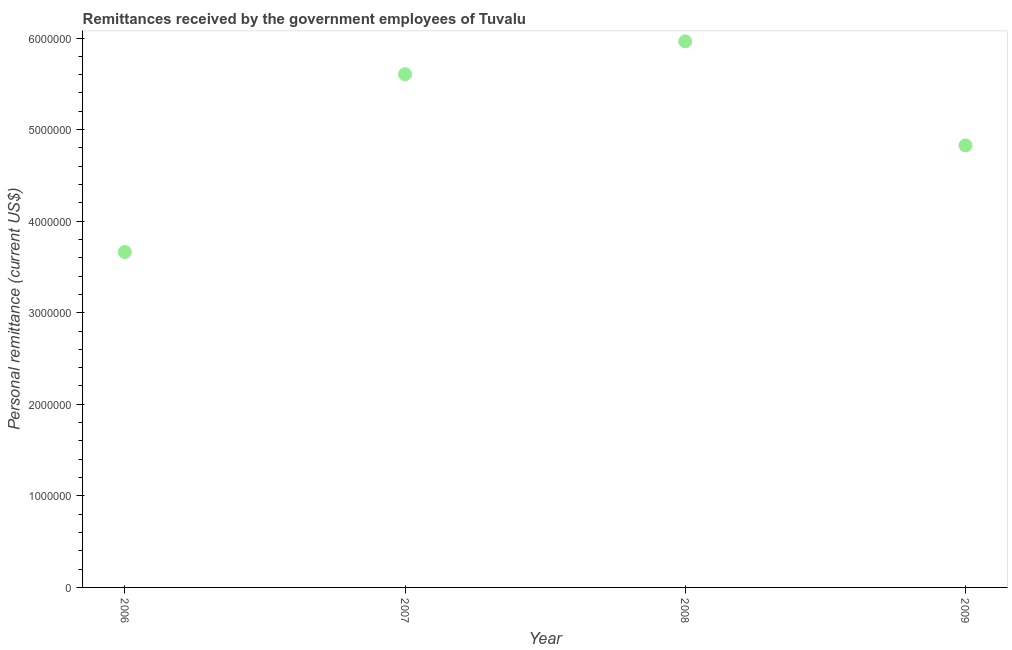What is the personal remittances in 2008?
Ensure brevity in your answer.  5.96e+06. Across all years, what is the maximum personal remittances?
Give a very brief answer. 5.96e+06. Across all years, what is the minimum personal remittances?
Provide a short and direct response. 3.66e+06. What is the sum of the personal remittances?
Provide a short and direct response. 2.01e+07. What is the difference between the personal remittances in 2007 and 2009?
Your answer should be compact. 7.78e+05. What is the average personal remittances per year?
Your answer should be very brief. 5.01e+06. What is the median personal remittances?
Make the answer very short. 5.22e+06. Do a majority of the years between 2009 and 2006 (inclusive) have personal remittances greater than 4800000 US$?
Give a very brief answer. Yes. What is the ratio of the personal remittances in 2007 to that in 2008?
Offer a very short reply. 0.94. What is the difference between the highest and the second highest personal remittances?
Ensure brevity in your answer.  3.59e+05. What is the difference between the highest and the lowest personal remittances?
Ensure brevity in your answer.  2.30e+06. In how many years, is the personal remittances greater than the average personal remittances taken over all years?
Ensure brevity in your answer.  2. Does the personal remittances monotonically increase over the years?
Offer a very short reply. No. How many dotlines are there?
Give a very brief answer. 1. How many years are there in the graph?
Keep it short and to the point. 4. Are the values on the major ticks of Y-axis written in scientific E-notation?
Offer a very short reply. No. What is the title of the graph?
Make the answer very short. Remittances received by the government employees of Tuvalu. What is the label or title of the X-axis?
Give a very brief answer. Year. What is the label or title of the Y-axis?
Provide a short and direct response. Personal remittance (current US$). What is the Personal remittance (current US$) in 2006?
Ensure brevity in your answer.  3.66e+06. What is the Personal remittance (current US$) in 2007?
Your response must be concise. 5.60e+06. What is the Personal remittance (current US$) in 2008?
Your answer should be compact. 5.96e+06. What is the Personal remittance (current US$) in 2009?
Offer a very short reply. 4.83e+06. What is the difference between the Personal remittance (current US$) in 2006 and 2007?
Give a very brief answer. -1.94e+06. What is the difference between the Personal remittance (current US$) in 2006 and 2008?
Your answer should be compact. -2.30e+06. What is the difference between the Personal remittance (current US$) in 2006 and 2009?
Provide a short and direct response. -1.16e+06. What is the difference between the Personal remittance (current US$) in 2007 and 2008?
Provide a short and direct response. -3.59e+05. What is the difference between the Personal remittance (current US$) in 2007 and 2009?
Ensure brevity in your answer.  7.78e+05. What is the difference between the Personal remittance (current US$) in 2008 and 2009?
Ensure brevity in your answer.  1.14e+06. What is the ratio of the Personal remittance (current US$) in 2006 to that in 2007?
Your answer should be compact. 0.65. What is the ratio of the Personal remittance (current US$) in 2006 to that in 2008?
Keep it short and to the point. 0.61. What is the ratio of the Personal remittance (current US$) in 2006 to that in 2009?
Make the answer very short. 0.76. What is the ratio of the Personal remittance (current US$) in 2007 to that in 2009?
Make the answer very short. 1.16. What is the ratio of the Personal remittance (current US$) in 2008 to that in 2009?
Offer a terse response. 1.24. 